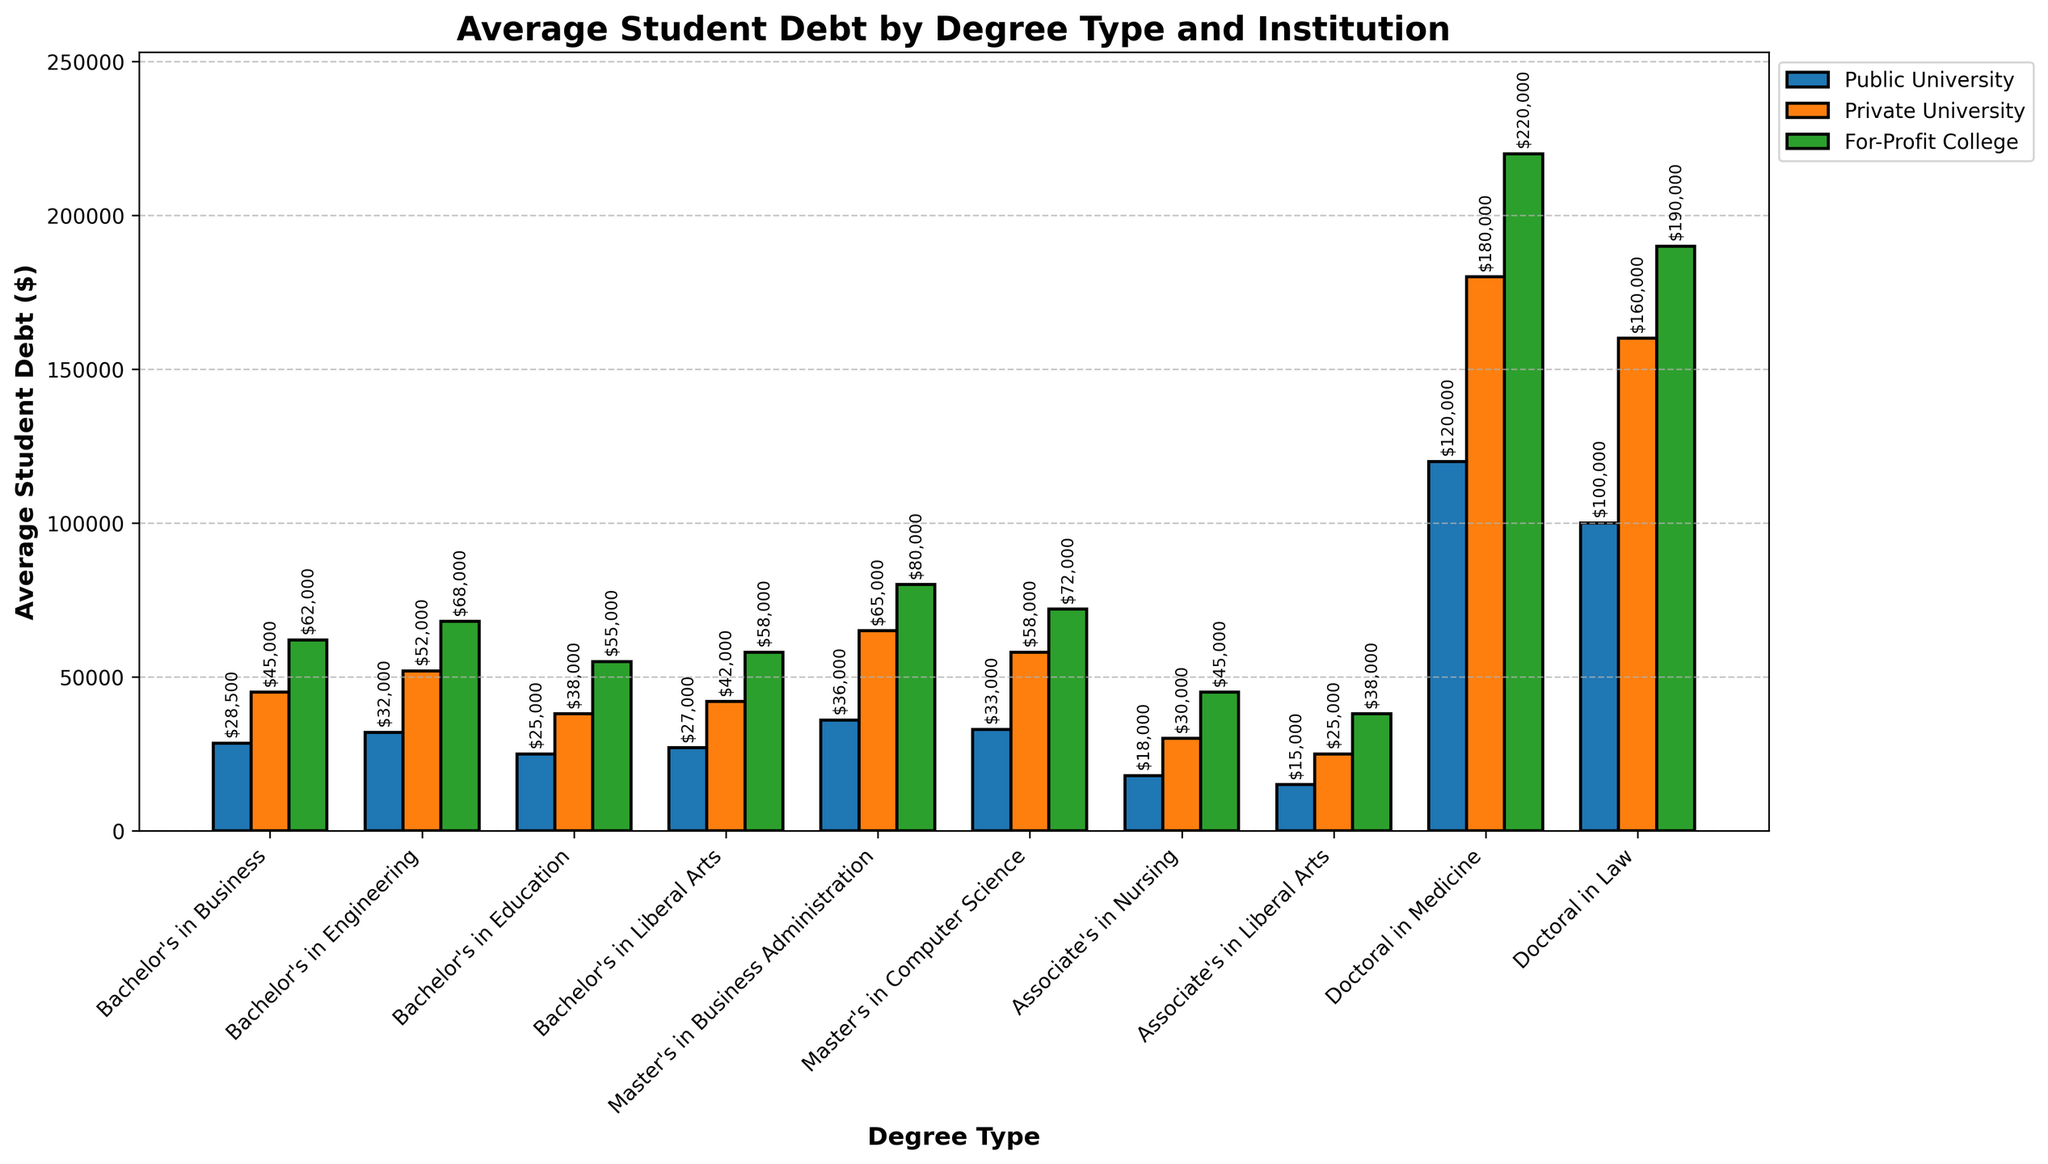Which degree has the highest average student debt at a public university? Look at the bars for public universities and identify the tallest one. The tallest bar represents the doctoral in medicine degree.
Answer: Doctoral in Medicine Which institution type generally results in the highest average student debt for a master's degree in business administration? Compare the bars for the MBA degree across all institution types and identify which one is the tallest. The tallest bar represents for-profit colleges.
Answer: For-Profit College How much more is the average student debt for a bachelor's in engineering at a private university compared to a public university? Find the heights of the bars for both public and private universities for the bachelor's in engineering degree, then subtract the two values. The private university bar is $52,000 and the public university bar is $32,000. $52,000 - $32,000 = $20,000.
Answer: $20,000 What is the average student debt difference between a bachelor's in liberal arts and a master's in computer science at a public university? Find the heights of the bars corresponding to these degrees at public universities, then subtract them. Bachelor’s in liberal arts: $27,000, master’s in computer science: $33,000. $33,000 - $27,000 = $6,000.
Answer: $6,000 Compare the student debt for a doctoral in law at a private university and a master's in business administration at a for-profit college. Which one is higher? Find the heights of the bars corresponding to the doctoral in law at private universities and MBA at for-profit colleges. The heights are $160,000 for the private university doctoral in law and $80,000 for the for-profit college MBA, so the doctoral in law debt is higher.
Answer: Doctoral in Law at Private University Which degree at for-profit colleges has the lowest average student debt, and what is that amount? Look at the bars for for-profit colleges and identify the shortest one. The shortest bar represents the associates in liberal arts degree, which has an average debt of $38,000.
Answer: Associate's in Liberal Arts, $38,000 By how much does student debt for doctoral degrees at public universities exceed those for master's degrees at private universities on average? Calculate the average debt for all doctoral degrees at public universities and all master's degrees at private universities. Public doctoral: (120,000 + 100,000)/2 = $110,000. Private master's: (65,000 + 58,000)/2 = $61,500. $110,000 - $61,500 = $48,500.
Answer: $48,500 What is the combined average debt for bachelor's and associate's degrees at public universities? Add the debts for all bachelor's and associate's degrees at public universities. (28,500 + 32,000 + 25,000 + 27,000 + 18,000 + 15,000) = $145,500.
Answer: $145,500 